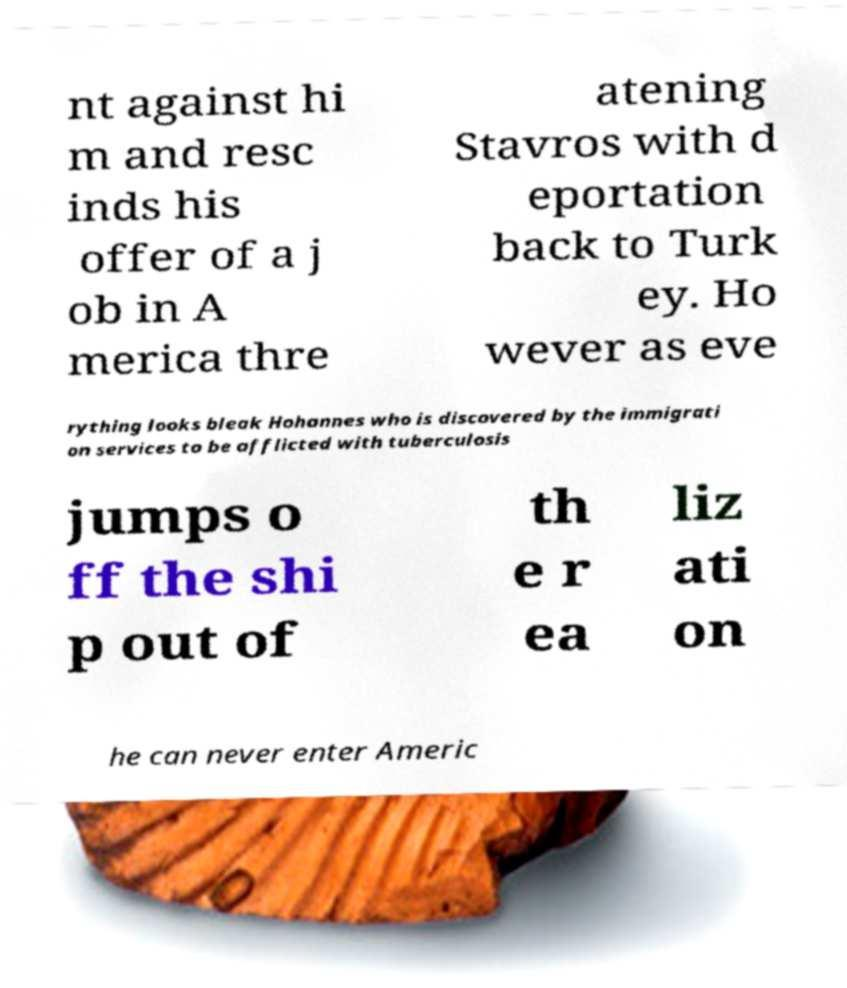There's text embedded in this image that I need extracted. Can you transcribe it verbatim? nt against hi m and resc inds his offer of a j ob in A merica thre atening Stavros with d eportation back to Turk ey. Ho wever as eve rything looks bleak Hohannes who is discovered by the immigrati on services to be afflicted with tuberculosis jumps o ff the shi p out of th e r ea liz ati on he can never enter Americ 